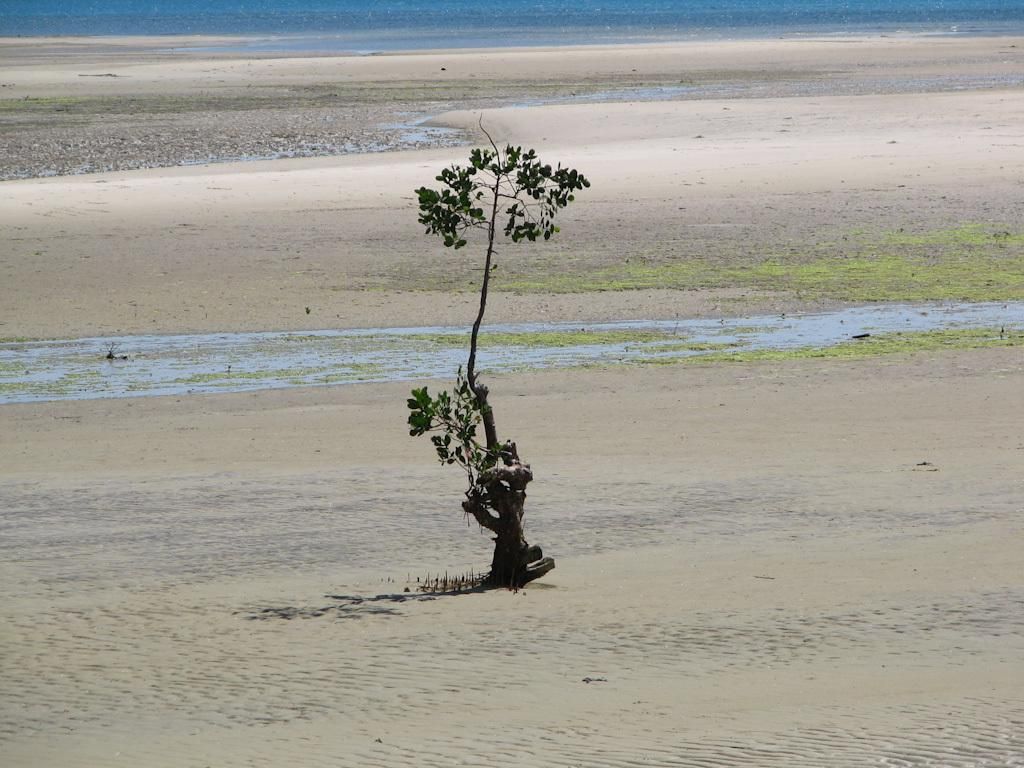What is located on the ground in the image? There is a plant on the ground in the image. What type of vegetation is present on the ground? Some part of the ground is covered with grass. What can be seen in the distance in the image? Water is visible in the distance. What direction is the bedroom facing in the image? There is no bedroom present in the image. Is there a fire visible in the image? There is no fire present in the image. 